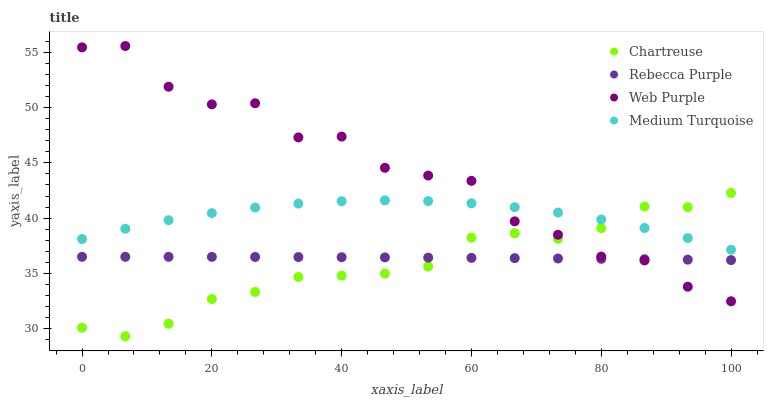Does Chartreuse have the minimum area under the curve?
Answer yes or no. Yes. Does Web Purple have the maximum area under the curve?
Answer yes or no. Yes. Does Rebecca Purple have the minimum area under the curve?
Answer yes or no. No. Does Rebecca Purple have the maximum area under the curve?
Answer yes or no. No. Is Rebecca Purple the smoothest?
Answer yes or no. Yes. Is Web Purple the roughest?
Answer yes or no. Yes. Is Chartreuse the smoothest?
Answer yes or no. No. Is Chartreuse the roughest?
Answer yes or no. No. Does Chartreuse have the lowest value?
Answer yes or no. Yes. Does Rebecca Purple have the lowest value?
Answer yes or no. No. Does Web Purple have the highest value?
Answer yes or no. Yes. Does Chartreuse have the highest value?
Answer yes or no. No. Is Rebecca Purple less than Medium Turquoise?
Answer yes or no. Yes. Is Medium Turquoise greater than Rebecca Purple?
Answer yes or no. Yes. Does Chartreuse intersect Rebecca Purple?
Answer yes or no. Yes. Is Chartreuse less than Rebecca Purple?
Answer yes or no. No. Is Chartreuse greater than Rebecca Purple?
Answer yes or no. No. Does Rebecca Purple intersect Medium Turquoise?
Answer yes or no. No. 